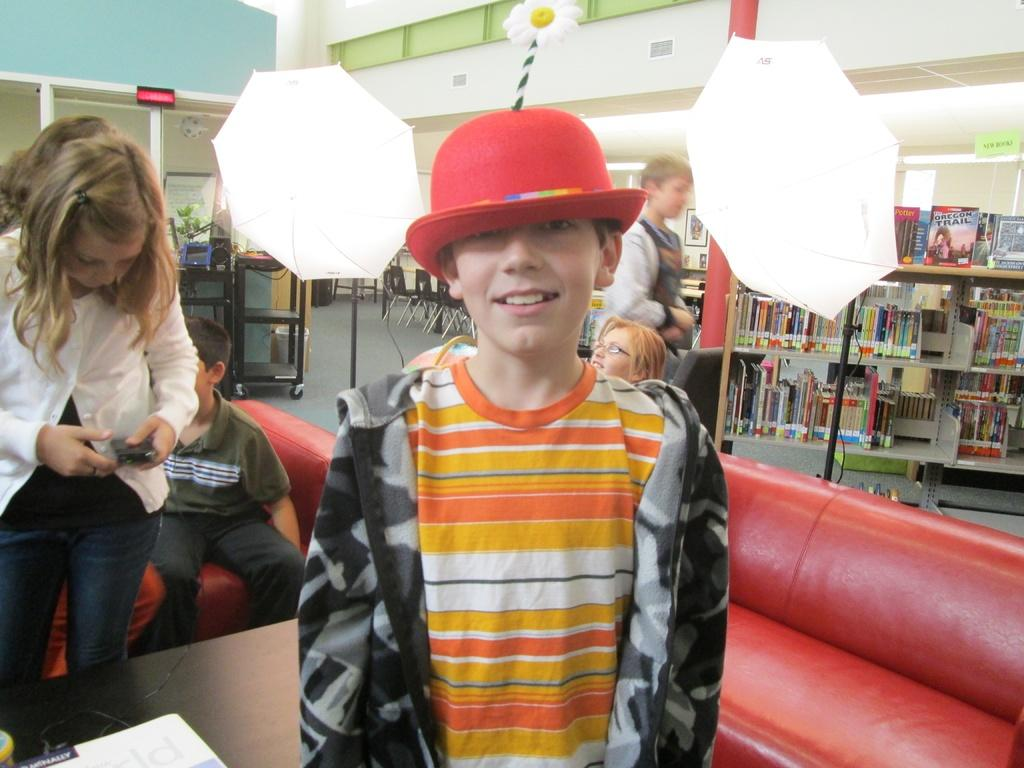What type of furniture is present in the image? There are sofas in the image. What can be seen on the walls in the image? There are shelves in the image. What is providing illumination in the image? There are lights in the image. Can you describe the person in the image? There is a person standing in the middle of the image. What type of chalk is the person using to draw on the sofas in the image? There is no chalk present in the image, and the person is not drawing on the sofas. How many bags can be seen on the shelves in the image? There are no bags visible on the shelves in the image. 